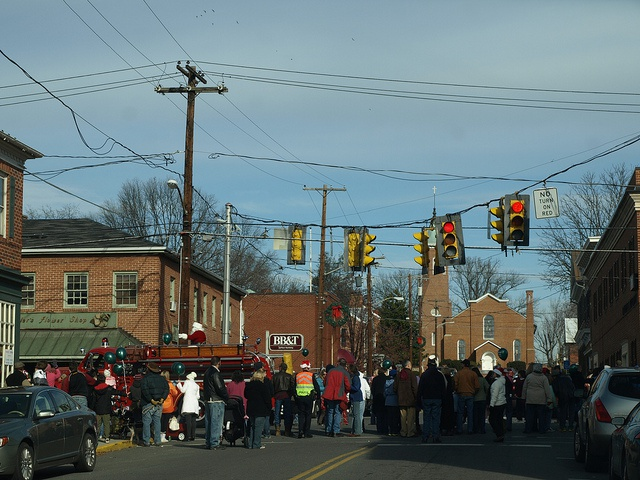Describe the objects in this image and their specific colors. I can see car in darkgray, black, gray, purple, and darkblue tones, people in darkgray, black, gray, ivory, and maroon tones, car in darkgray, black, gray, purple, and darkblue tones, truck in darkgray, black, maroon, and gray tones, and car in darkgray, black, purple, teal, and darkblue tones in this image. 